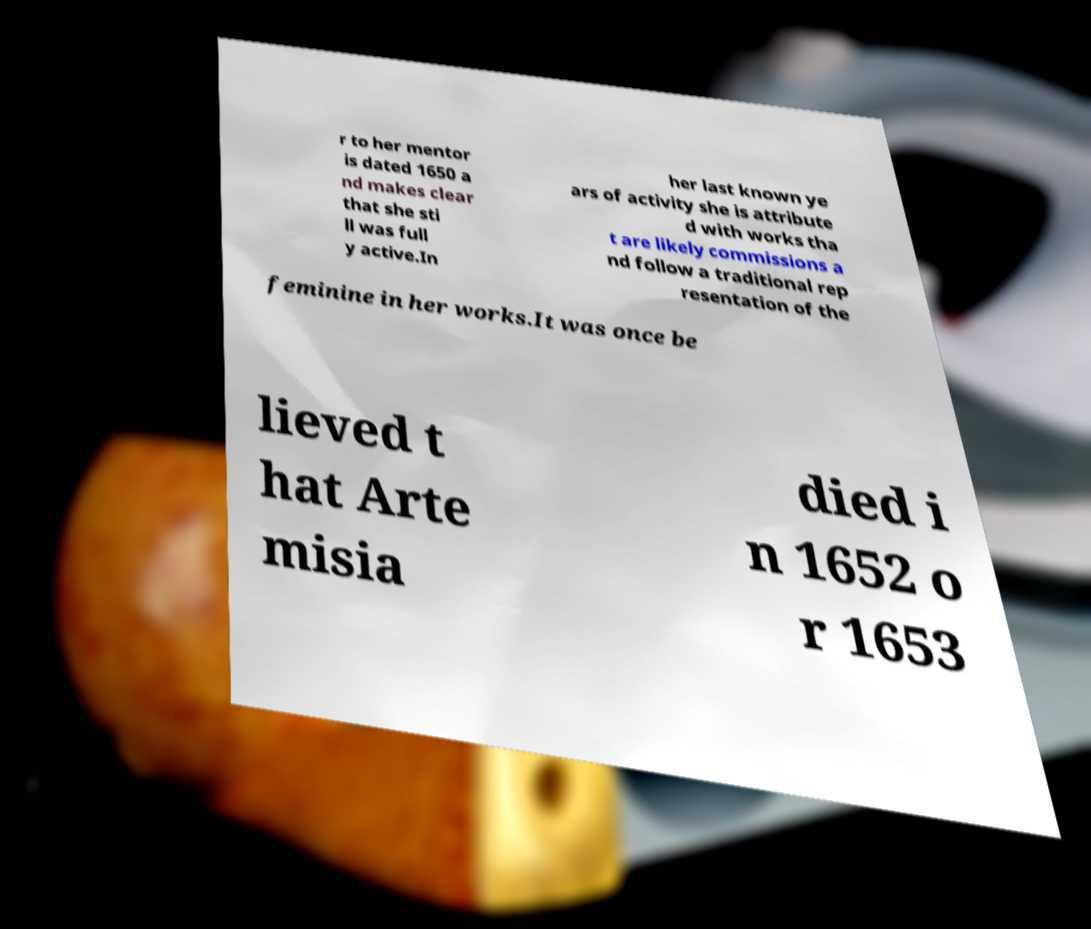I need the written content from this picture converted into text. Can you do that? r to her mentor is dated 1650 a nd makes clear that she sti ll was full y active.In her last known ye ars of activity she is attribute d with works tha t are likely commissions a nd follow a traditional rep resentation of the feminine in her works.It was once be lieved t hat Arte misia died i n 1652 o r 1653 